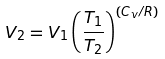Convert formula to latex. <formula><loc_0><loc_0><loc_500><loc_500>V _ { 2 } = V _ { 1 } \left ( { \frac { T _ { 1 } } { T _ { 2 } } } \right ) ^ { ( C _ { v } / R ) }</formula> 